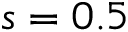Convert formula to latex. <formula><loc_0><loc_0><loc_500><loc_500>s = 0 . 5</formula> 